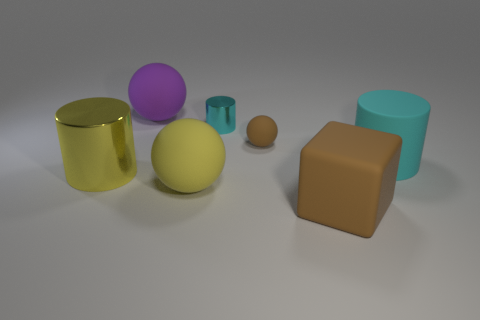Add 2 large green matte blocks. How many objects exist? 9 Subtract all balls. How many objects are left? 4 Add 6 big purple metallic things. How many big purple metallic things exist? 6 Subtract 1 purple balls. How many objects are left? 6 Subtract all blue metallic cylinders. Subtract all tiny metallic things. How many objects are left? 6 Add 4 small brown rubber spheres. How many small brown rubber spheres are left? 5 